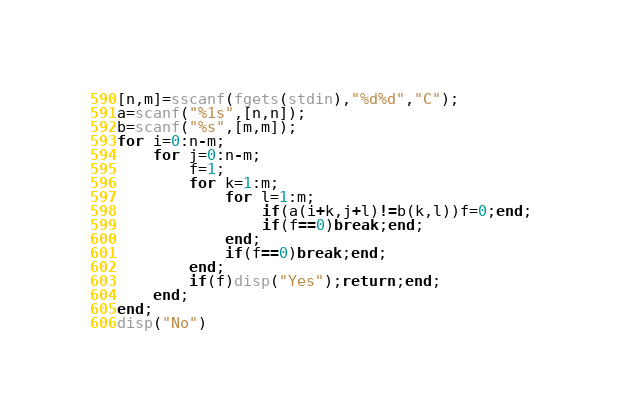Convert code to text. <code><loc_0><loc_0><loc_500><loc_500><_Octave_>[n,m]=sscanf(fgets(stdin),"%d%d","C");
a=scanf("%1s",[n,n]);
b=scanf("%s",[m,m]);
for i=0:n-m;
	for j=0:n-m;
		f=1;
		for k=1:m;
			for l=1:m;
				if(a(i+k,j+l)!=b(k,l))f=0;end;
                if(f==0)break;end;
			end;
            if(f==0)break;end;
		end;
		if(f)disp("Yes");return;end;
	end;
end;
disp("No")
</code> 